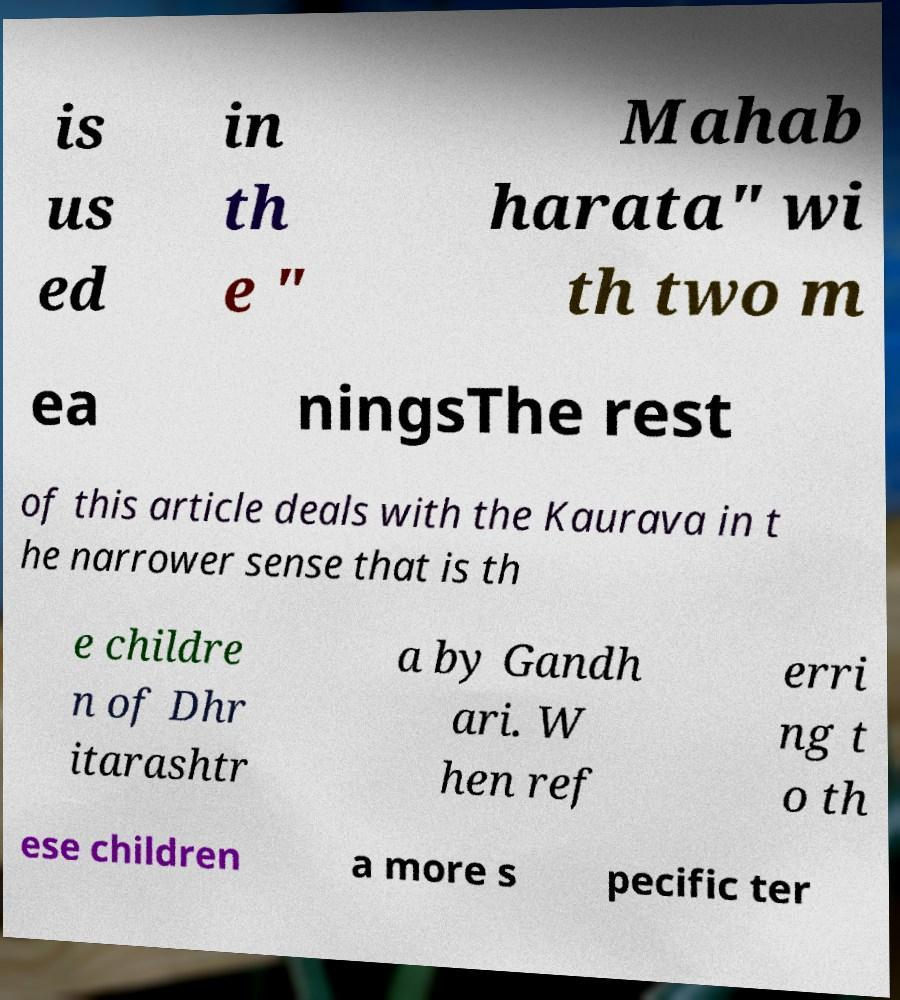For documentation purposes, I need the text within this image transcribed. Could you provide that? is us ed in th e " Mahab harata" wi th two m ea ningsThe rest of this article deals with the Kaurava in t he narrower sense that is th e childre n of Dhr itarashtr a by Gandh ari. W hen ref erri ng t o th ese children a more s pecific ter 